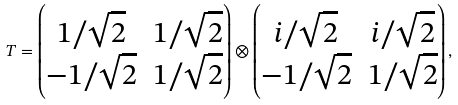Convert formula to latex. <formula><loc_0><loc_0><loc_500><loc_500>T = \begin{pmatrix} 1 / \sqrt { 2 } & 1 / \sqrt { 2 } \\ - 1 / \sqrt { 2 } & 1 / \sqrt { 2 } \end{pmatrix} \otimes \begin{pmatrix} i / \sqrt { 2 } & i / \sqrt { 2 } \\ - 1 / \sqrt { 2 } & 1 / \sqrt { 2 } \end{pmatrix} ,</formula> 